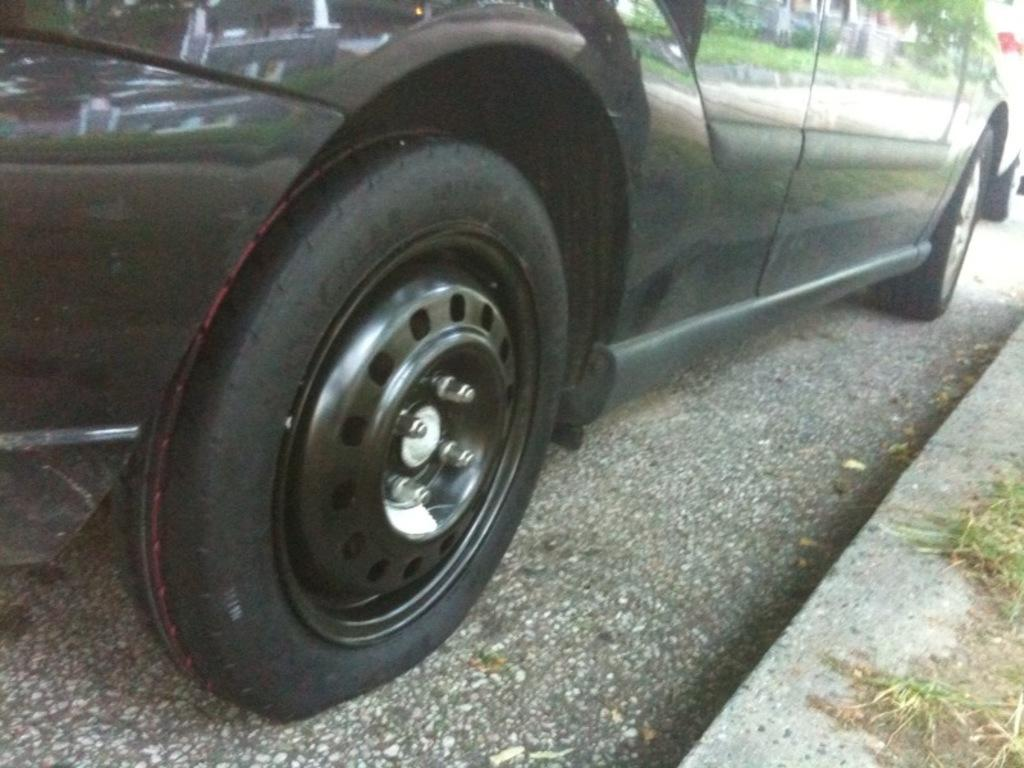What is the main subject of the image? There is a vehicle in the image. Where is the vehicle located? The vehicle is on the road. What can be seen in the vehicle's reflection? The vehicle's reflection shows grass, a tree, and a building. What type of stick is being used to hold the flag on the shelf in the image? There is no stick, flag, or shelf present in the image. 